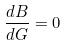<formula> <loc_0><loc_0><loc_500><loc_500>\frac { d B } { d G } = 0</formula> 